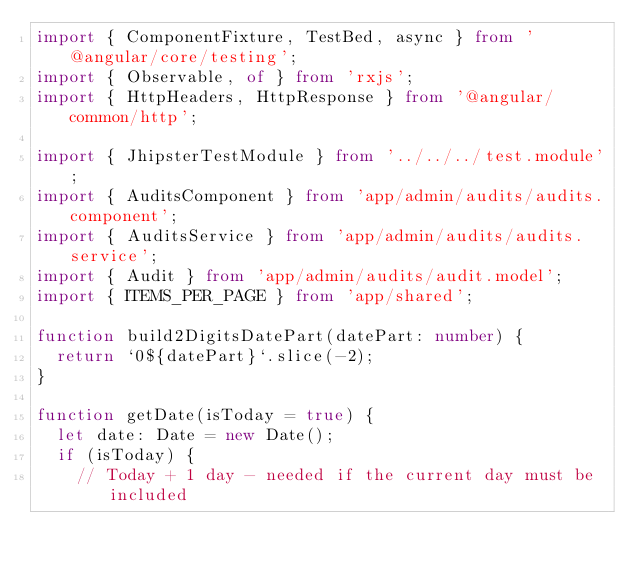Convert code to text. <code><loc_0><loc_0><loc_500><loc_500><_TypeScript_>import { ComponentFixture, TestBed, async } from '@angular/core/testing';
import { Observable, of } from 'rxjs';
import { HttpHeaders, HttpResponse } from '@angular/common/http';

import { JhipsterTestModule } from '../../../test.module';
import { AuditsComponent } from 'app/admin/audits/audits.component';
import { AuditsService } from 'app/admin/audits/audits.service';
import { Audit } from 'app/admin/audits/audit.model';
import { ITEMS_PER_PAGE } from 'app/shared';

function build2DigitsDatePart(datePart: number) {
  return `0${datePart}`.slice(-2);
}

function getDate(isToday = true) {
  let date: Date = new Date();
  if (isToday) {
    // Today + 1 day - needed if the current day must be included</code> 